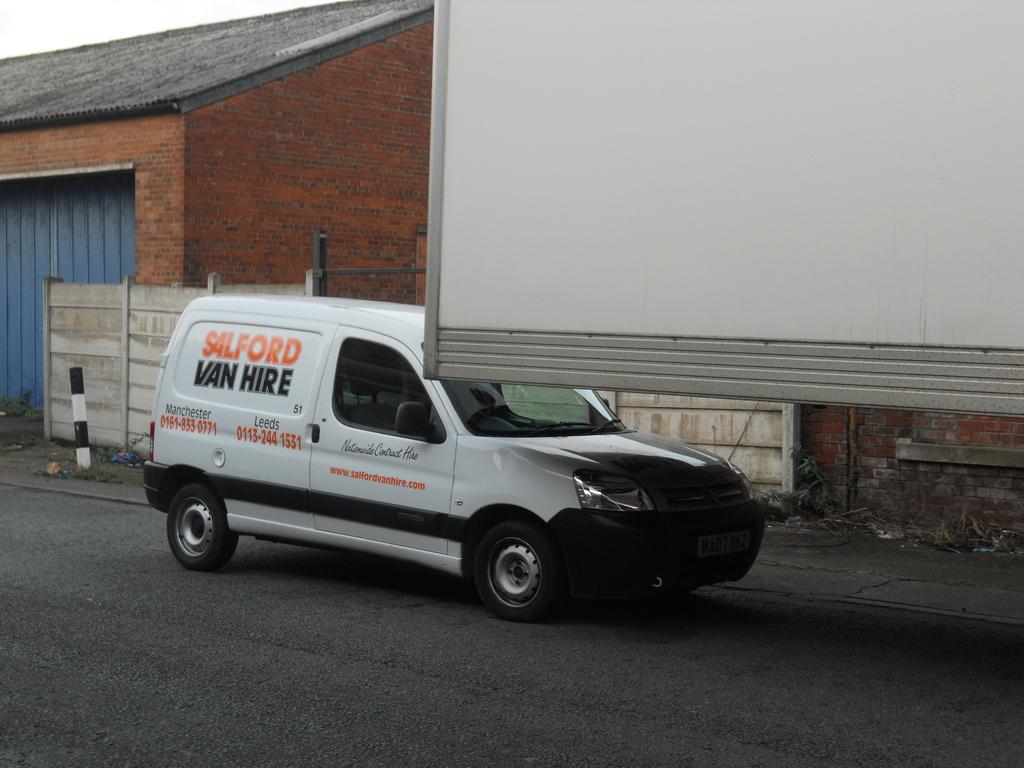<image>
Give a short and clear explanation of the subsequent image. A white Sailford Van Lines van is parked next to a trailer in front of a brick building. 